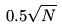<formula> <loc_0><loc_0><loc_500><loc_500>0 . 5 \sqrt { N }</formula> 